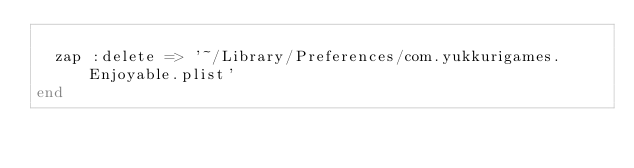Convert code to text. <code><loc_0><loc_0><loc_500><loc_500><_Ruby_>
  zap :delete => '~/Library/Preferences/com.yukkurigames.Enjoyable.plist'
end
</code> 